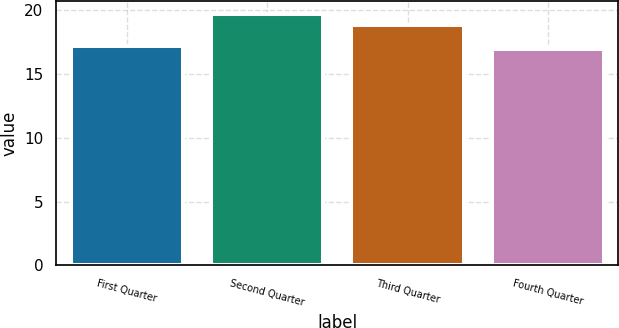Convert chart. <chart><loc_0><loc_0><loc_500><loc_500><bar_chart><fcel>First Quarter<fcel>Second Quarter<fcel>Third Quarter<fcel>Fourth Quarter<nl><fcel>17.21<fcel>19.72<fcel>18.85<fcel>16.93<nl></chart> 